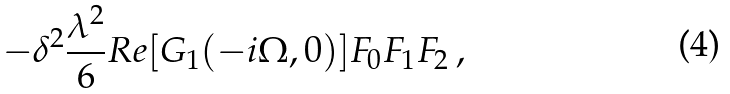<formula> <loc_0><loc_0><loc_500><loc_500>- \delta ^ { 2 } \frac { \lambda ^ { 2 } } { 6 } R e [ G _ { 1 } ( - i \Omega , { 0 } ) ] F _ { 0 } F _ { 1 } F _ { 2 } \, ,</formula> 